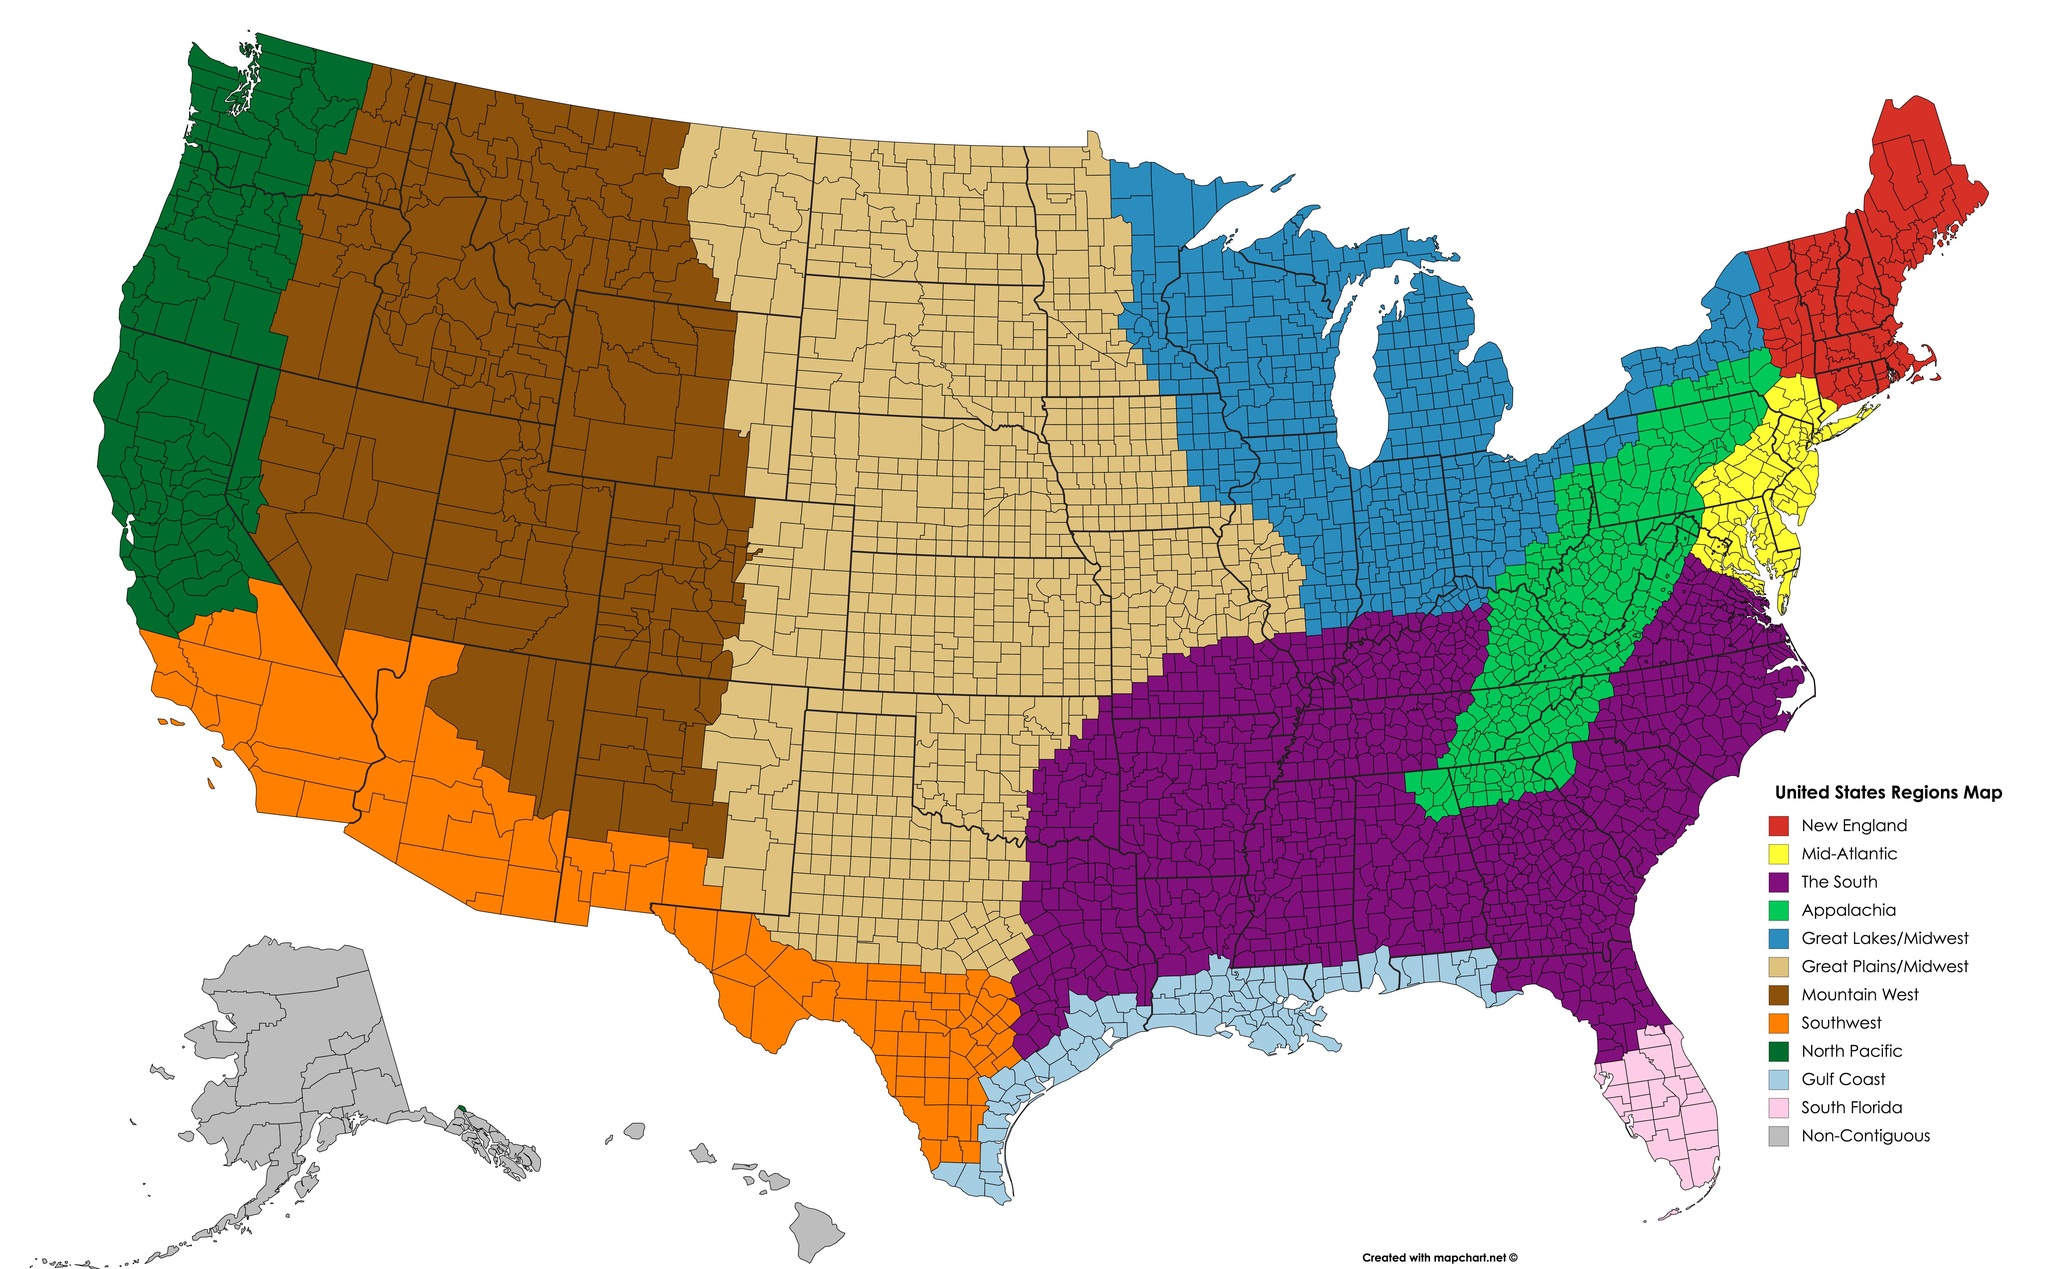Mention a couple of crucial points in this snapshot. The region to the west of Mountain West is the North Pacific, which is located in the Western United States. The color of the Mid-Atlantic region is yellow. The region that lies to the south of the Mountain West region is the Southwest region. The Great Plains/Midwest region lies east of the Mountain West region. The number of regions listed on the map is 12. 